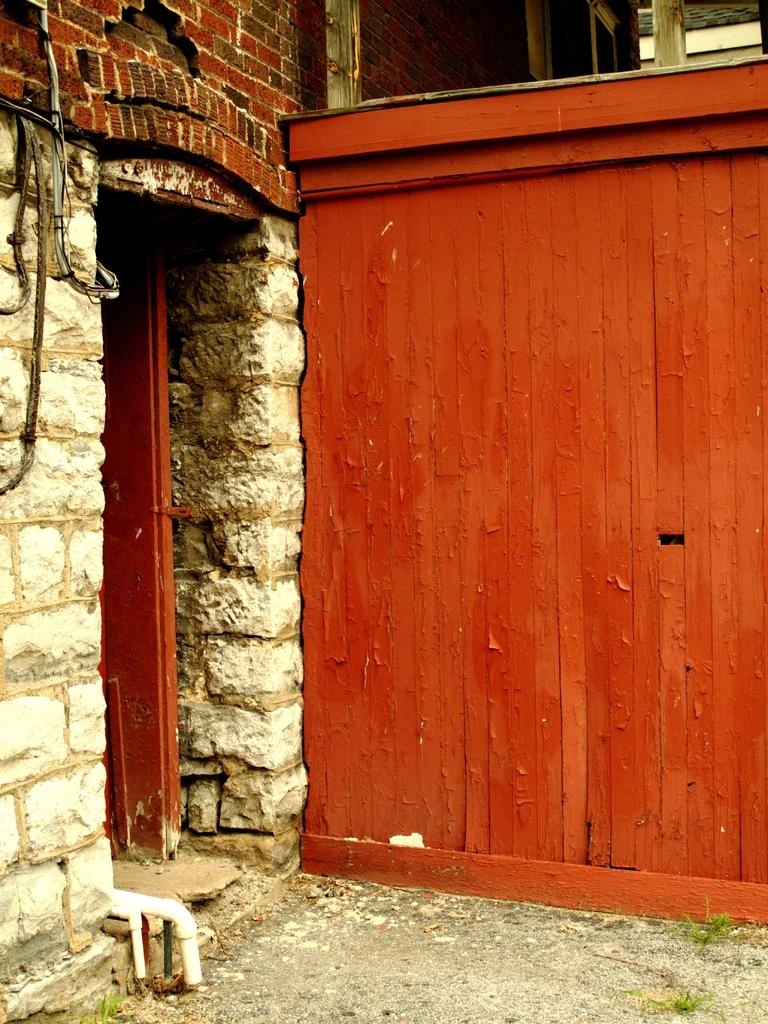What type of structure can be seen in the image? There is a wall in the image. Is there an entrance visible in the image? Yes, there is a door in the image. What else can be seen in the image besides the wall and door? There are pipes visible in the image. What is the surface visible at the bottom of the image? The ground is visible at the bottom of the image. Can you see any fish swimming in the image? No, there are no fish present in the image. Is there a chessboard visible in the image? No, there is no chessboard present in the image. 